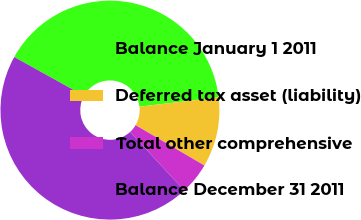<chart> <loc_0><loc_0><loc_500><loc_500><pie_chart><fcel>Balance January 1 2011<fcel>Deferred tax asset (liability)<fcel>Total other comprehensive<fcel>Balance December 31 2011<nl><fcel>40.08%<fcel>10.3%<fcel>4.68%<fcel>44.94%<nl></chart> 